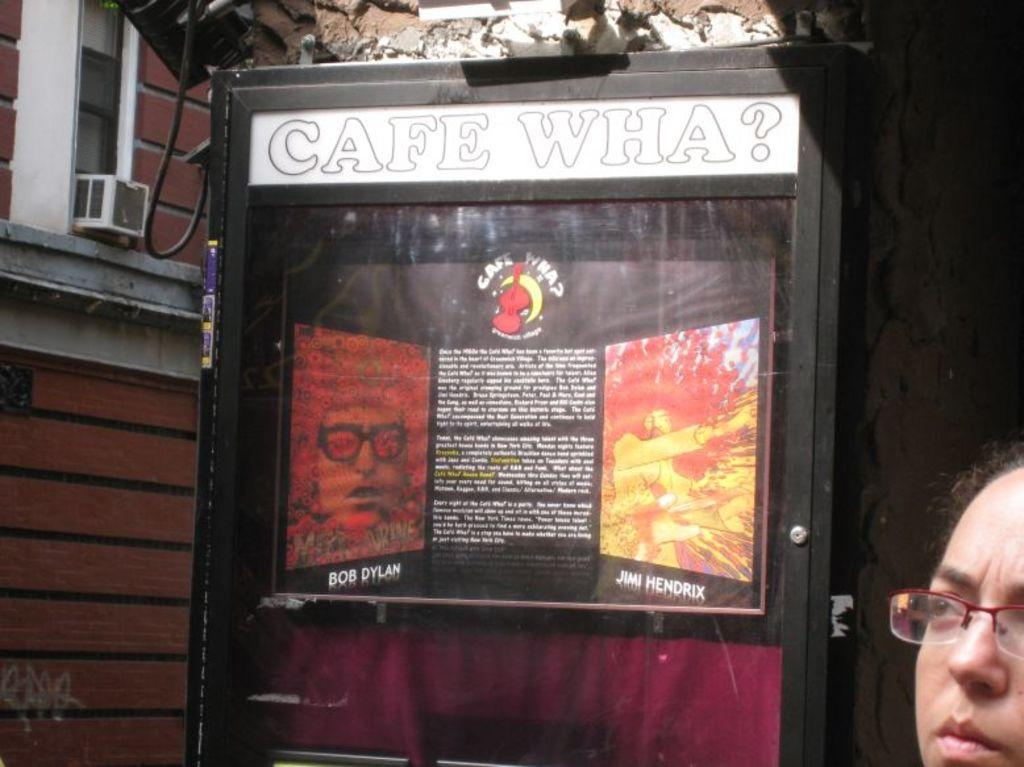What is the main object in the image? There is a board in the image. What material is present in the image? Glass is present in the image. What type of structure can be seen in the image? There is a wall in the image. What feature allows light and air to enter the room in the image? There is a window in the image. Can you describe the object in the image? There is an object in the image, but its specific details are not mentioned in the facts. Where is the person's face visible in the image? The person's face is visible in the bottom right side of the image. What type of net is being used to catch the spot in the image? There is no mention of a spot or a net in the image. 